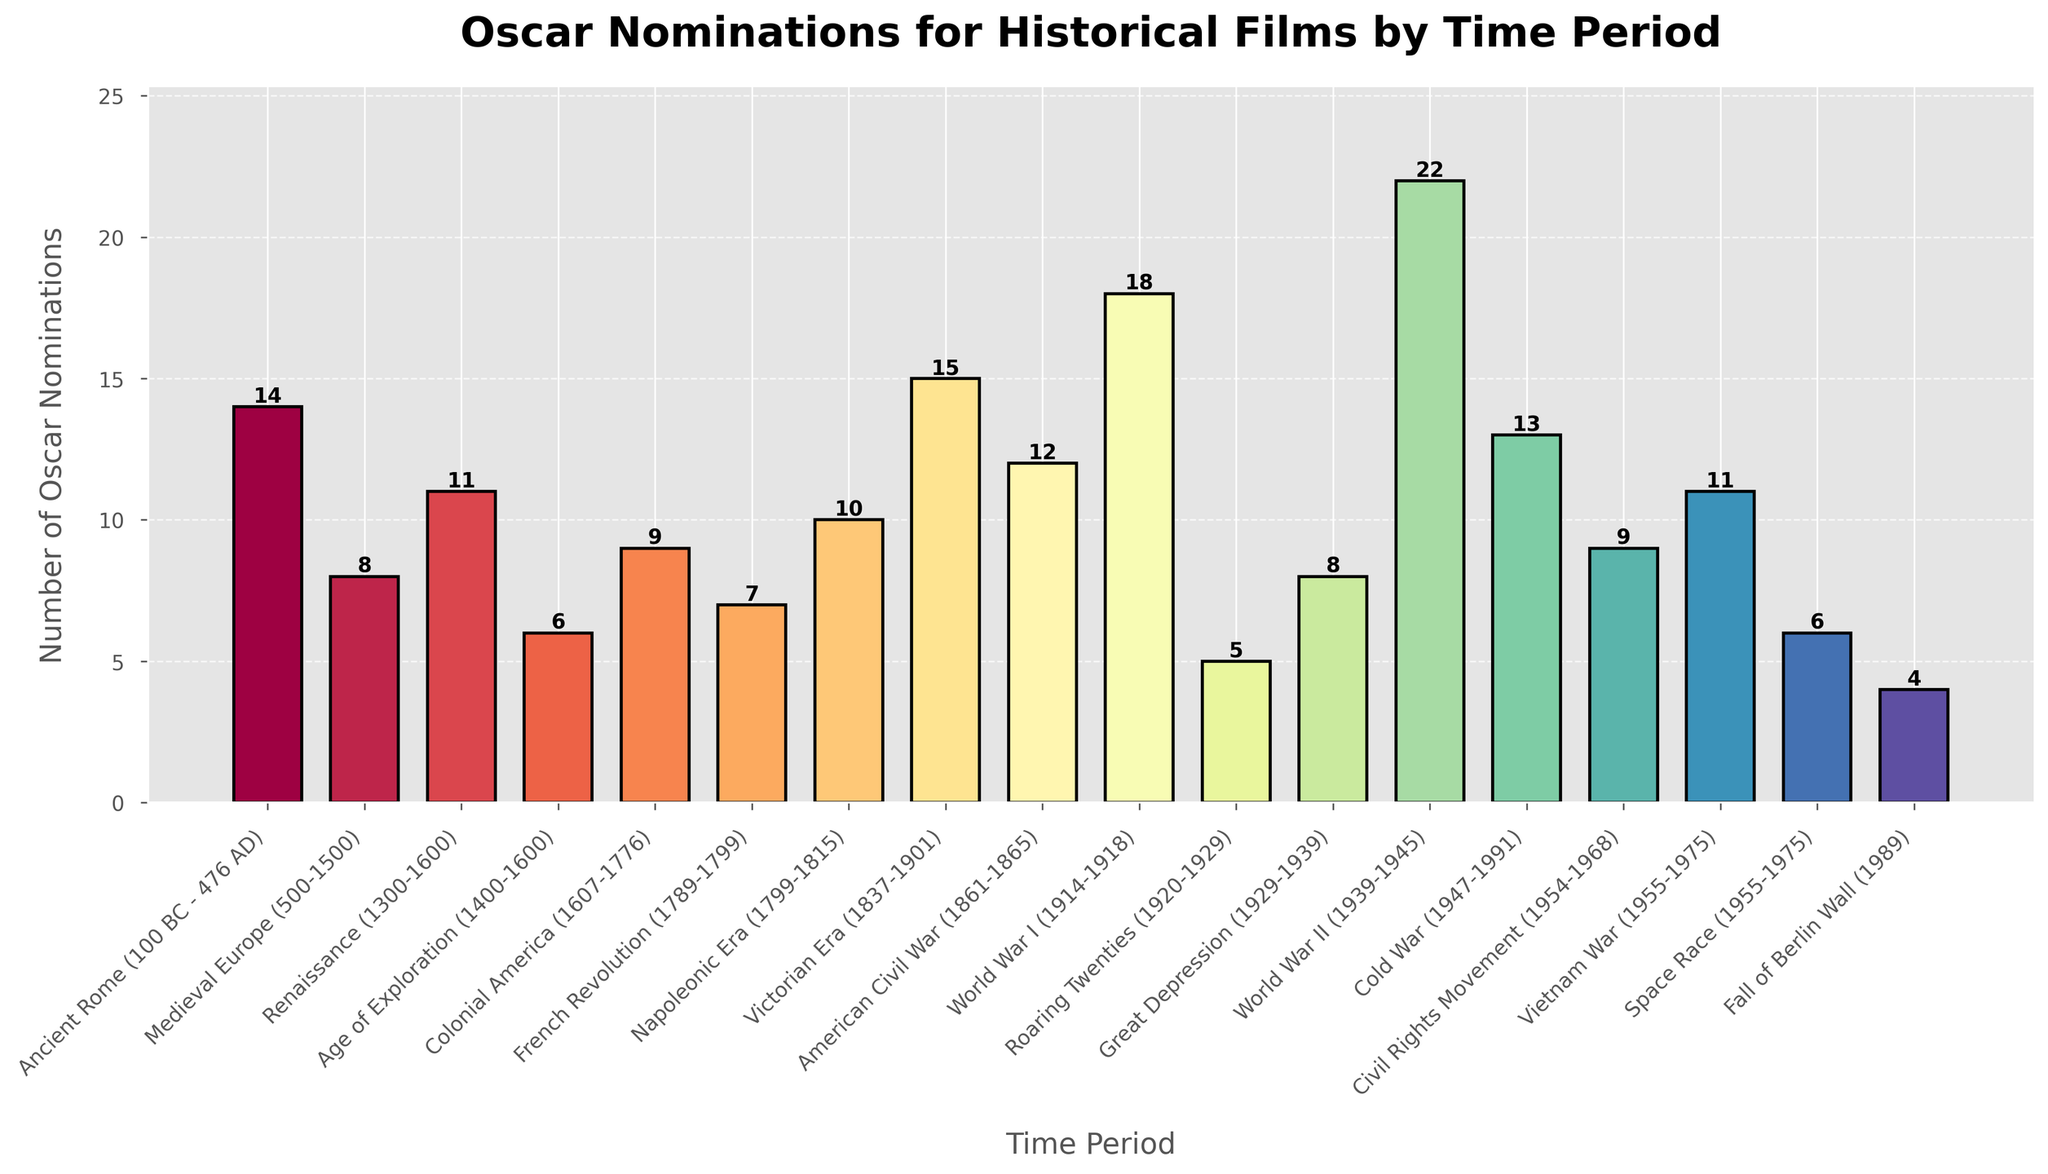What time period received the most Oscar nominations? Look for the highest bar in the chart and read the corresponding time period.
Answer: World War II Which time period had more Oscar nominations, the French Revolution or the Napoleonic Era? Compare the heights of the bars for the French Revolution and the Napoleonic Era. The Napoleonic Era's bar is taller, indicating more nominations.
Answer: Napoleonic Era What is the combined total of Oscar nominations for the American Civil War and the Civil Rights Movement periods? Add the Oscar nominations for the American Civil War (12) and the Civil Rights Movement (9). 12 + 9 = 21.
Answer: 21 Which two time periods received the least Oscar nominations? Identify the two shortest bars on the chart.
Answer: Fall of Berlin Wall and Roaring Twenties Is the number of Oscar nominations for the Victorian Era greater than the nominations for Ancient Rome? Compare the heights of the bars for the Victorian Era and Ancient Rome. The Victorian Era's bar is taller.
Answer: Yes How many more nominations did World War II receive compared to the Roaring Twenties? Subtract the number of nominations for the Roaring Twenties (5) from those for World War II (22). 22 - 5 = 17.
Answer: 17 Which time period between the Great Depression and the Age of Exploration had more Oscar nominations? Compare the heights of the bars for the Great Depression and the Age of Exploration. The Great Depression's bar is taller.
Answer: Great Depression What is the average number of Oscar nominations for time periods from the Middle Ages to the Napoleon Era (500-1815)? Sum the Oscar nominations for Medieval Europe (8), Renaissance (11), Age of Exploration (6), Colonial America (9), French Revolution (7), and Napoleonic Era (10), then divide by the number of periods (6). (8 + 11 + 6 + 9 + 7 + 10) / 6 = 8.5.
Answer: 8.5 Which time period had fewer nominations, the Space Race or Colonial America? Compare the heights of the bars for the Space Race and Colonial America. The Space Race's bar is shorter.
Answer: Space Race How many historical periods received more than 10 Oscar nominations? Count the number of bars that have heights higher than 10 on the y-axis.
Answer: 5 